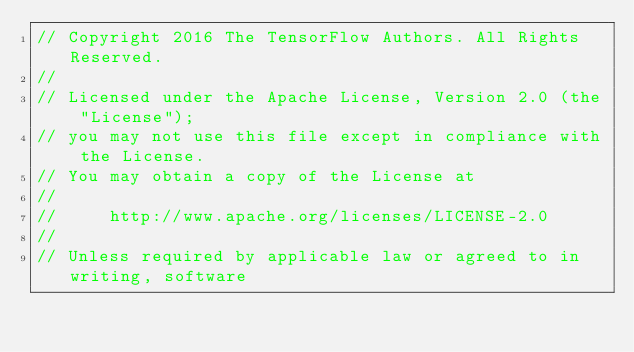<code> <loc_0><loc_0><loc_500><loc_500><_C++_>// Copyright 2016 The TensorFlow Authors. All Rights Reserved.
//
// Licensed under the Apache License, Version 2.0 (the "License");
// you may not use this file except in compliance with the License.
// You may obtain a copy of the License at
//
//     http://www.apache.org/licenses/LICENSE-2.0
//
// Unless required by applicable law or agreed to in writing, software</code> 